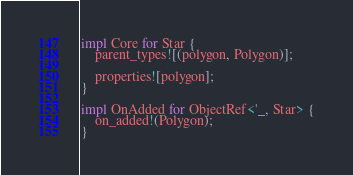Convert code to text. <code><loc_0><loc_0><loc_500><loc_500><_Rust_>
impl Core for Star {
    parent_types![(polygon, Polygon)];

    properties![polygon];
}

impl OnAdded for ObjectRef<'_, Star> {
    on_added!(Polygon);
}
</code> 